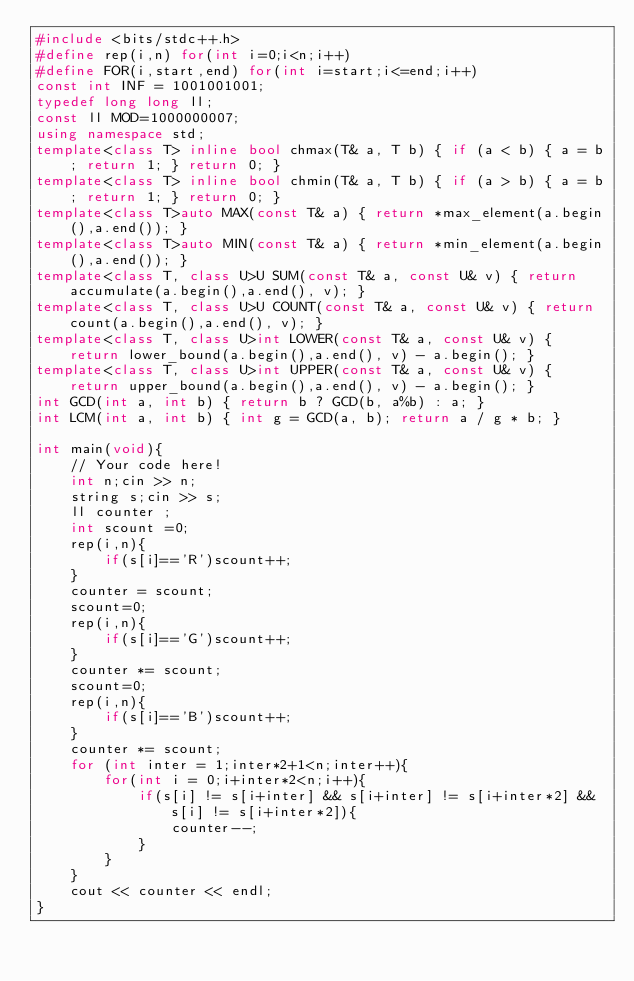Convert code to text. <code><loc_0><loc_0><loc_500><loc_500><_C++_>#include <bits/stdc++.h>
#define rep(i,n) for(int i=0;i<n;i++)
#define FOR(i,start,end) for(int i=start;i<=end;i++)
const int INF = 1001001001;
typedef long long ll;
const ll MOD=1000000007;
using namespace std;
template<class T> inline bool chmax(T& a, T b) { if (a < b) { a = b; return 1; } return 0; }
template<class T> inline bool chmin(T& a, T b) { if (a > b) { a = b; return 1; } return 0; }
template<class T>auto MAX(const T& a) { return *max_element(a.begin(),a.end()); }
template<class T>auto MIN(const T& a) { return *min_element(a.begin(),a.end()); }
template<class T, class U>U SUM(const T& a, const U& v) { return accumulate(a.begin(),a.end(), v); }
template<class T, class U>U COUNT(const T& a, const U& v) { return count(a.begin(),a.end(), v); }
template<class T, class U>int LOWER(const T& a, const U& v) { return lower_bound(a.begin(),a.end(), v) - a.begin(); }
template<class T, class U>int UPPER(const T& a, const U& v) { return upper_bound(a.begin(),a.end(), v) - a.begin(); }
int GCD(int a, int b) { return b ? GCD(b, a%b) : a; }
int LCM(int a, int b) { int g = GCD(a, b); return a / g * b; }

int main(void){
    // Your code here!
    int n;cin >> n;
    string s;cin >> s;
    ll counter ;
    int scount =0;
    rep(i,n){
        if(s[i]=='R')scount++;
    }
    counter = scount;
    scount=0;
    rep(i,n){
        if(s[i]=='G')scount++;
    }
    counter *= scount;
    scount=0;
    rep(i,n){
        if(s[i]=='B')scount++;
    }
    counter *= scount;
    for (int inter = 1;inter*2+1<n;inter++){
        for(int i = 0;i+inter*2<n;i++){
            if(s[i] != s[i+inter] && s[i+inter] != s[i+inter*2] && s[i] != s[i+inter*2]){
                counter--;
            }
        }
    }
    cout << counter << endl;
}
</code> 